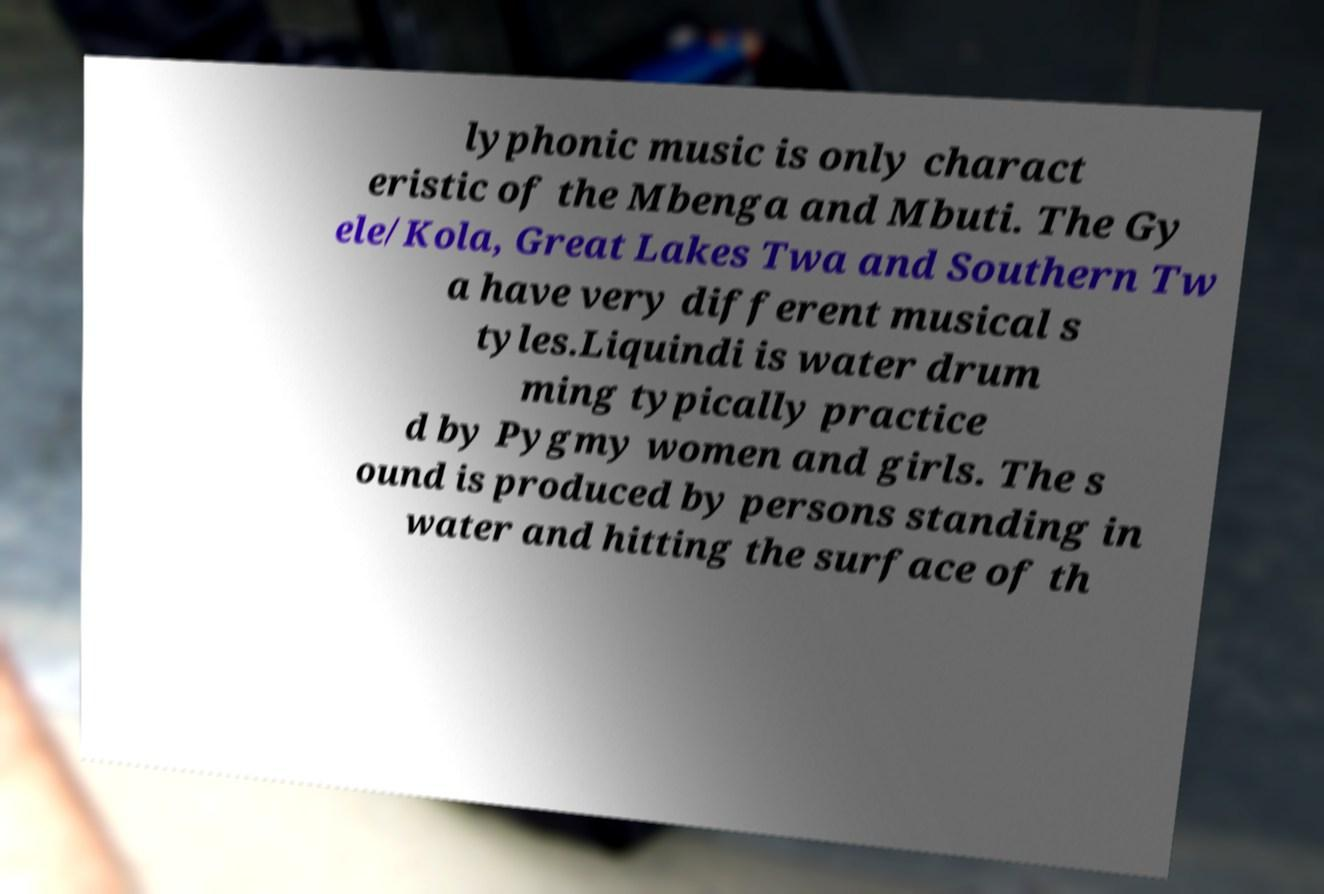Can you read and provide the text displayed in the image?This photo seems to have some interesting text. Can you extract and type it out for me? lyphonic music is only charact eristic of the Mbenga and Mbuti. The Gy ele/Kola, Great Lakes Twa and Southern Tw a have very different musical s tyles.Liquindi is water drum ming typically practice d by Pygmy women and girls. The s ound is produced by persons standing in water and hitting the surface of th 